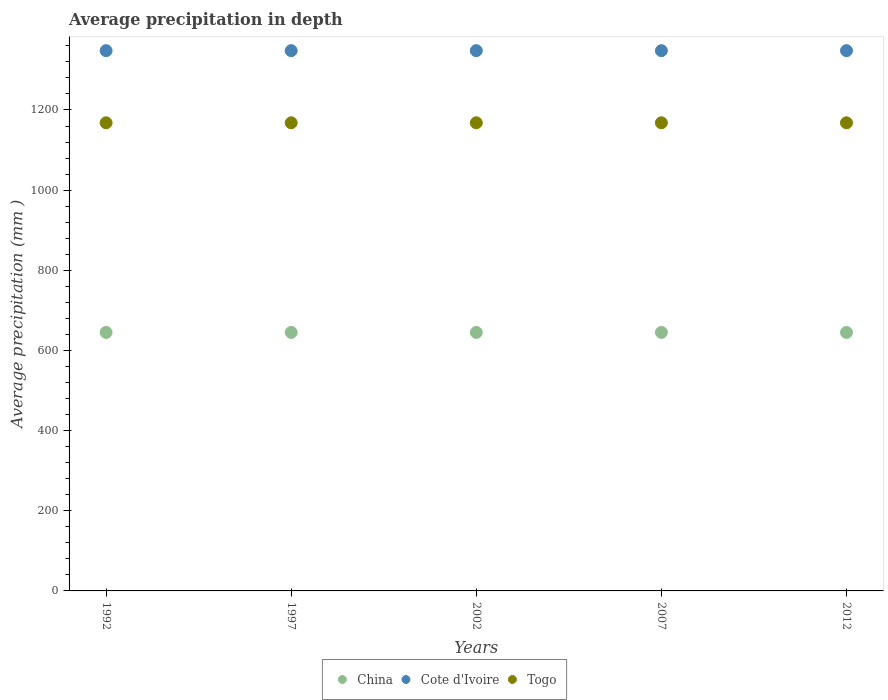What is the average precipitation in China in 2007?
Your answer should be compact. 645. Across all years, what is the maximum average precipitation in Cote d'Ivoire?
Your response must be concise. 1348. Across all years, what is the minimum average precipitation in Cote d'Ivoire?
Your answer should be very brief. 1348. What is the total average precipitation in Cote d'Ivoire in the graph?
Offer a very short reply. 6740. What is the difference between the average precipitation in Cote d'Ivoire in 2007 and that in 2012?
Keep it short and to the point. 0. What is the difference between the average precipitation in Togo in 2002 and the average precipitation in China in 1997?
Keep it short and to the point. 523. What is the average average precipitation in Togo per year?
Keep it short and to the point. 1168. In the year 2012, what is the difference between the average precipitation in Cote d'Ivoire and average precipitation in Togo?
Offer a terse response. 180. In how many years, is the average precipitation in Cote d'Ivoire greater than 440 mm?
Give a very brief answer. 5. Is the sum of the average precipitation in China in 1992 and 2012 greater than the maximum average precipitation in Cote d'Ivoire across all years?
Your answer should be compact. No. How many years are there in the graph?
Make the answer very short. 5. Does the graph contain any zero values?
Ensure brevity in your answer.  No. Does the graph contain grids?
Ensure brevity in your answer.  No. How many legend labels are there?
Your answer should be very brief. 3. What is the title of the graph?
Make the answer very short. Average precipitation in depth. Does "Indonesia" appear as one of the legend labels in the graph?
Provide a succinct answer. No. What is the label or title of the X-axis?
Keep it short and to the point. Years. What is the label or title of the Y-axis?
Offer a very short reply. Average precipitation (mm ). What is the Average precipitation (mm ) of China in 1992?
Keep it short and to the point. 645. What is the Average precipitation (mm ) of Cote d'Ivoire in 1992?
Provide a succinct answer. 1348. What is the Average precipitation (mm ) in Togo in 1992?
Your answer should be very brief. 1168. What is the Average precipitation (mm ) of China in 1997?
Keep it short and to the point. 645. What is the Average precipitation (mm ) in Cote d'Ivoire in 1997?
Provide a short and direct response. 1348. What is the Average precipitation (mm ) of Togo in 1997?
Make the answer very short. 1168. What is the Average precipitation (mm ) of China in 2002?
Offer a terse response. 645. What is the Average precipitation (mm ) of Cote d'Ivoire in 2002?
Give a very brief answer. 1348. What is the Average precipitation (mm ) in Togo in 2002?
Provide a short and direct response. 1168. What is the Average precipitation (mm ) of China in 2007?
Provide a short and direct response. 645. What is the Average precipitation (mm ) in Cote d'Ivoire in 2007?
Give a very brief answer. 1348. What is the Average precipitation (mm ) in Togo in 2007?
Offer a very short reply. 1168. What is the Average precipitation (mm ) of China in 2012?
Ensure brevity in your answer.  645. What is the Average precipitation (mm ) in Cote d'Ivoire in 2012?
Make the answer very short. 1348. What is the Average precipitation (mm ) of Togo in 2012?
Your answer should be compact. 1168. Across all years, what is the maximum Average precipitation (mm ) in China?
Ensure brevity in your answer.  645. Across all years, what is the maximum Average precipitation (mm ) of Cote d'Ivoire?
Offer a terse response. 1348. Across all years, what is the maximum Average precipitation (mm ) in Togo?
Keep it short and to the point. 1168. Across all years, what is the minimum Average precipitation (mm ) of China?
Keep it short and to the point. 645. Across all years, what is the minimum Average precipitation (mm ) of Cote d'Ivoire?
Provide a short and direct response. 1348. Across all years, what is the minimum Average precipitation (mm ) in Togo?
Provide a short and direct response. 1168. What is the total Average precipitation (mm ) in China in the graph?
Offer a very short reply. 3225. What is the total Average precipitation (mm ) of Cote d'Ivoire in the graph?
Your answer should be compact. 6740. What is the total Average precipitation (mm ) in Togo in the graph?
Your answer should be compact. 5840. What is the difference between the Average precipitation (mm ) in China in 1992 and that in 1997?
Make the answer very short. 0. What is the difference between the Average precipitation (mm ) of Cote d'Ivoire in 1992 and that in 2007?
Your answer should be very brief. 0. What is the difference between the Average precipitation (mm ) in Togo in 1992 and that in 2007?
Provide a short and direct response. 0. What is the difference between the Average precipitation (mm ) in Cote d'Ivoire in 1992 and that in 2012?
Offer a terse response. 0. What is the difference between the Average precipitation (mm ) of China in 1997 and that in 2007?
Your response must be concise. 0. What is the difference between the Average precipitation (mm ) of Cote d'Ivoire in 1997 and that in 2007?
Your answer should be very brief. 0. What is the difference between the Average precipitation (mm ) of Togo in 1997 and that in 2007?
Provide a succinct answer. 0. What is the difference between the Average precipitation (mm ) of Togo in 1997 and that in 2012?
Give a very brief answer. 0. What is the difference between the Average precipitation (mm ) in Cote d'Ivoire in 2002 and that in 2012?
Provide a succinct answer. 0. What is the difference between the Average precipitation (mm ) in Cote d'Ivoire in 2007 and that in 2012?
Your response must be concise. 0. What is the difference between the Average precipitation (mm ) in Togo in 2007 and that in 2012?
Offer a very short reply. 0. What is the difference between the Average precipitation (mm ) of China in 1992 and the Average precipitation (mm ) of Cote d'Ivoire in 1997?
Your answer should be compact. -703. What is the difference between the Average precipitation (mm ) in China in 1992 and the Average precipitation (mm ) in Togo in 1997?
Your response must be concise. -523. What is the difference between the Average precipitation (mm ) of Cote d'Ivoire in 1992 and the Average precipitation (mm ) of Togo in 1997?
Provide a short and direct response. 180. What is the difference between the Average precipitation (mm ) in China in 1992 and the Average precipitation (mm ) in Cote d'Ivoire in 2002?
Offer a very short reply. -703. What is the difference between the Average precipitation (mm ) of China in 1992 and the Average precipitation (mm ) of Togo in 2002?
Give a very brief answer. -523. What is the difference between the Average precipitation (mm ) in Cote d'Ivoire in 1992 and the Average precipitation (mm ) in Togo in 2002?
Keep it short and to the point. 180. What is the difference between the Average precipitation (mm ) of China in 1992 and the Average precipitation (mm ) of Cote d'Ivoire in 2007?
Provide a succinct answer. -703. What is the difference between the Average precipitation (mm ) of China in 1992 and the Average precipitation (mm ) of Togo in 2007?
Make the answer very short. -523. What is the difference between the Average precipitation (mm ) of Cote d'Ivoire in 1992 and the Average precipitation (mm ) of Togo in 2007?
Give a very brief answer. 180. What is the difference between the Average precipitation (mm ) in China in 1992 and the Average precipitation (mm ) in Cote d'Ivoire in 2012?
Make the answer very short. -703. What is the difference between the Average precipitation (mm ) of China in 1992 and the Average precipitation (mm ) of Togo in 2012?
Your response must be concise. -523. What is the difference between the Average precipitation (mm ) in Cote d'Ivoire in 1992 and the Average precipitation (mm ) in Togo in 2012?
Offer a terse response. 180. What is the difference between the Average precipitation (mm ) in China in 1997 and the Average precipitation (mm ) in Cote d'Ivoire in 2002?
Make the answer very short. -703. What is the difference between the Average precipitation (mm ) in China in 1997 and the Average precipitation (mm ) in Togo in 2002?
Provide a succinct answer. -523. What is the difference between the Average precipitation (mm ) of Cote d'Ivoire in 1997 and the Average precipitation (mm ) of Togo in 2002?
Your answer should be compact. 180. What is the difference between the Average precipitation (mm ) in China in 1997 and the Average precipitation (mm ) in Cote d'Ivoire in 2007?
Provide a succinct answer. -703. What is the difference between the Average precipitation (mm ) of China in 1997 and the Average precipitation (mm ) of Togo in 2007?
Provide a succinct answer. -523. What is the difference between the Average precipitation (mm ) of Cote d'Ivoire in 1997 and the Average precipitation (mm ) of Togo in 2007?
Make the answer very short. 180. What is the difference between the Average precipitation (mm ) of China in 1997 and the Average precipitation (mm ) of Cote d'Ivoire in 2012?
Offer a very short reply. -703. What is the difference between the Average precipitation (mm ) in China in 1997 and the Average precipitation (mm ) in Togo in 2012?
Offer a terse response. -523. What is the difference between the Average precipitation (mm ) of Cote d'Ivoire in 1997 and the Average precipitation (mm ) of Togo in 2012?
Your answer should be very brief. 180. What is the difference between the Average precipitation (mm ) of China in 2002 and the Average precipitation (mm ) of Cote d'Ivoire in 2007?
Your answer should be compact. -703. What is the difference between the Average precipitation (mm ) in China in 2002 and the Average precipitation (mm ) in Togo in 2007?
Offer a terse response. -523. What is the difference between the Average precipitation (mm ) of Cote d'Ivoire in 2002 and the Average precipitation (mm ) of Togo in 2007?
Offer a very short reply. 180. What is the difference between the Average precipitation (mm ) in China in 2002 and the Average precipitation (mm ) in Cote d'Ivoire in 2012?
Offer a very short reply. -703. What is the difference between the Average precipitation (mm ) in China in 2002 and the Average precipitation (mm ) in Togo in 2012?
Offer a terse response. -523. What is the difference between the Average precipitation (mm ) of Cote d'Ivoire in 2002 and the Average precipitation (mm ) of Togo in 2012?
Provide a short and direct response. 180. What is the difference between the Average precipitation (mm ) of China in 2007 and the Average precipitation (mm ) of Cote d'Ivoire in 2012?
Your answer should be compact. -703. What is the difference between the Average precipitation (mm ) in China in 2007 and the Average precipitation (mm ) in Togo in 2012?
Your response must be concise. -523. What is the difference between the Average precipitation (mm ) of Cote d'Ivoire in 2007 and the Average precipitation (mm ) of Togo in 2012?
Give a very brief answer. 180. What is the average Average precipitation (mm ) in China per year?
Keep it short and to the point. 645. What is the average Average precipitation (mm ) in Cote d'Ivoire per year?
Provide a short and direct response. 1348. What is the average Average precipitation (mm ) in Togo per year?
Your answer should be very brief. 1168. In the year 1992, what is the difference between the Average precipitation (mm ) of China and Average precipitation (mm ) of Cote d'Ivoire?
Provide a succinct answer. -703. In the year 1992, what is the difference between the Average precipitation (mm ) in China and Average precipitation (mm ) in Togo?
Your answer should be compact. -523. In the year 1992, what is the difference between the Average precipitation (mm ) in Cote d'Ivoire and Average precipitation (mm ) in Togo?
Keep it short and to the point. 180. In the year 1997, what is the difference between the Average precipitation (mm ) of China and Average precipitation (mm ) of Cote d'Ivoire?
Offer a very short reply. -703. In the year 1997, what is the difference between the Average precipitation (mm ) in China and Average precipitation (mm ) in Togo?
Provide a short and direct response. -523. In the year 1997, what is the difference between the Average precipitation (mm ) in Cote d'Ivoire and Average precipitation (mm ) in Togo?
Offer a terse response. 180. In the year 2002, what is the difference between the Average precipitation (mm ) of China and Average precipitation (mm ) of Cote d'Ivoire?
Provide a succinct answer. -703. In the year 2002, what is the difference between the Average precipitation (mm ) of China and Average precipitation (mm ) of Togo?
Ensure brevity in your answer.  -523. In the year 2002, what is the difference between the Average precipitation (mm ) in Cote d'Ivoire and Average precipitation (mm ) in Togo?
Provide a succinct answer. 180. In the year 2007, what is the difference between the Average precipitation (mm ) in China and Average precipitation (mm ) in Cote d'Ivoire?
Ensure brevity in your answer.  -703. In the year 2007, what is the difference between the Average precipitation (mm ) of China and Average precipitation (mm ) of Togo?
Provide a succinct answer. -523. In the year 2007, what is the difference between the Average precipitation (mm ) of Cote d'Ivoire and Average precipitation (mm ) of Togo?
Ensure brevity in your answer.  180. In the year 2012, what is the difference between the Average precipitation (mm ) of China and Average precipitation (mm ) of Cote d'Ivoire?
Give a very brief answer. -703. In the year 2012, what is the difference between the Average precipitation (mm ) of China and Average precipitation (mm ) of Togo?
Your answer should be very brief. -523. In the year 2012, what is the difference between the Average precipitation (mm ) of Cote d'Ivoire and Average precipitation (mm ) of Togo?
Your response must be concise. 180. What is the ratio of the Average precipitation (mm ) in China in 1992 to that in 1997?
Your answer should be very brief. 1. What is the ratio of the Average precipitation (mm ) in Togo in 1992 to that in 1997?
Your answer should be very brief. 1. What is the ratio of the Average precipitation (mm ) of Cote d'Ivoire in 1992 to that in 2002?
Ensure brevity in your answer.  1. What is the ratio of the Average precipitation (mm ) of Togo in 1992 to that in 2002?
Give a very brief answer. 1. What is the ratio of the Average precipitation (mm ) in China in 1992 to that in 2007?
Keep it short and to the point. 1. What is the ratio of the Average precipitation (mm ) of Cote d'Ivoire in 1992 to that in 2007?
Your answer should be compact. 1. What is the ratio of the Average precipitation (mm ) in Cote d'Ivoire in 1992 to that in 2012?
Provide a succinct answer. 1. What is the ratio of the Average precipitation (mm ) of Togo in 1992 to that in 2012?
Keep it short and to the point. 1. What is the ratio of the Average precipitation (mm ) in Cote d'Ivoire in 1997 to that in 2002?
Offer a very short reply. 1. What is the ratio of the Average precipitation (mm ) in Togo in 1997 to that in 2007?
Your response must be concise. 1. What is the ratio of the Average precipitation (mm ) of China in 1997 to that in 2012?
Keep it short and to the point. 1. What is the ratio of the Average precipitation (mm ) in China in 2002 to that in 2007?
Give a very brief answer. 1. What is the ratio of the Average precipitation (mm ) in Cote d'Ivoire in 2002 to that in 2007?
Make the answer very short. 1. What is the ratio of the Average precipitation (mm ) in Togo in 2002 to that in 2007?
Your answer should be very brief. 1. What is the ratio of the Average precipitation (mm ) in China in 2002 to that in 2012?
Offer a very short reply. 1. What is the ratio of the Average precipitation (mm ) in Togo in 2002 to that in 2012?
Provide a short and direct response. 1. What is the ratio of the Average precipitation (mm ) of Cote d'Ivoire in 2007 to that in 2012?
Keep it short and to the point. 1. What is the ratio of the Average precipitation (mm ) of Togo in 2007 to that in 2012?
Your response must be concise. 1. What is the difference between the highest and the second highest Average precipitation (mm ) of China?
Your answer should be compact. 0. What is the difference between the highest and the second highest Average precipitation (mm ) of Cote d'Ivoire?
Ensure brevity in your answer.  0. What is the difference between the highest and the second highest Average precipitation (mm ) of Togo?
Your answer should be compact. 0. 